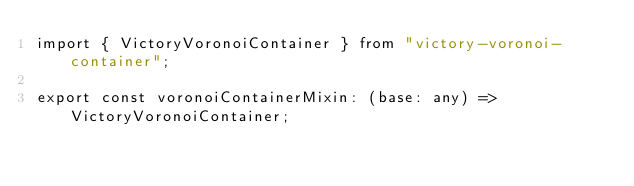Convert code to text. <code><loc_0><loc_0><loc_500><loc_500><_TypeScript_>import { VictoryVoronoiContainer } from "victory-voronoi-container";

export const voronoiContainerMixin: (base: any) => VictoryVoronoiContainer;
</code> 